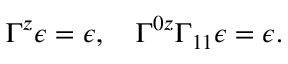<formula> <loc_0><loc_0><loc_500><loc_500>\Gamma ^ { z } \epsilon = \epsilon , \quad \Gamma ^ { 0 z } \Gamma _ { 1 1 } \epsilon = \epsilon .</formula> 